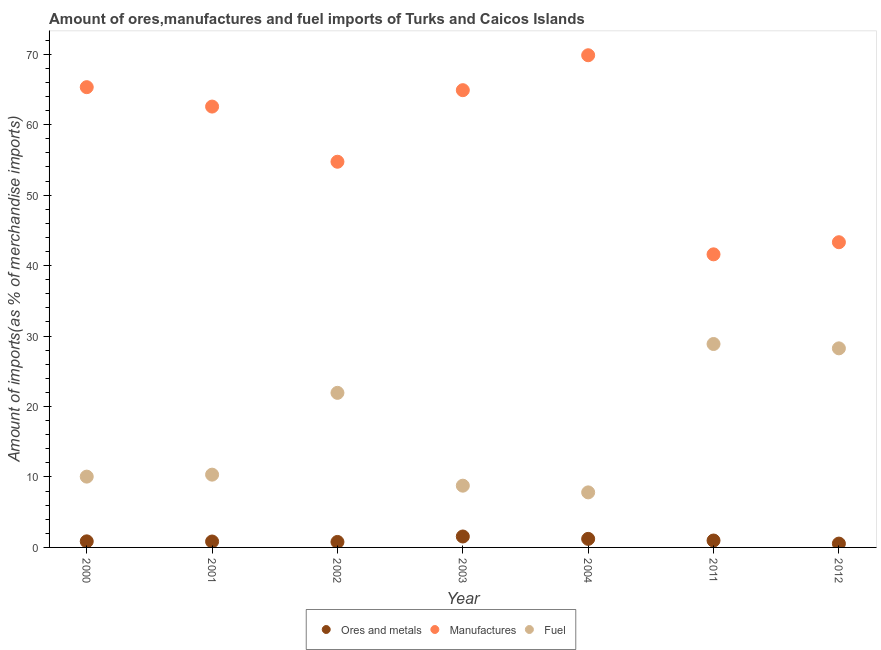What is the percentage of fuel imports in 2000?
Make the answer very short. 10.05. Across all years, what is the maximum percentage of ores and metals imports?
Your response must be concise. 1.55. Across all years, what is the minimum percentage of fuel imports?
Provide a short and direct response. 7.81. What is the total percentage of manufactures imports in the graph?
Offer a very short reply. 402.31. What is the difference between the percentage of ores and metals imports in 2000 and that in 2003?
Your answer should be very brief. -0.69. What is the difference between the percentage of fuel imports in 2012 and the percentage of ores and metals imports in 2004?
Ensure brevity in your answer.  27.04. What is the average percentage of manufactures imports per year?
Make the answer very short. 57.47. In the year 2001, what is the difference between the percentage of manufactures imports and percentage of fuel imports?
Your response must be concise. 52.24. In how many years, is the percentage of fuel imports greater than 14 %?
Provide a succinct answer. 3. What is the ratio of the percentage of manufactures imports in 2000 to that in 2012?
Your answer should be compact. 1.51. Is the percentage of ores and metals imports in 2000 less than that in 2002?
Offer a very short reply. No. What is the difference between the highest and the second highest percentage of ores and metals imports?
Your response must be concise. 0.34. What is the difference between the highest and the lowest percentage of ores and metals imports?
Your response must be concise. 1.01. Is the sum of the percentage of ores and metals imports in 2003 and 2012 greater than the maximum percentage of manufactures imports across all years?
Provide a succinct answer. No. How many dotlines are there?
Make the answer very short. 3. Are the values on the major ticks of Y-axis written in scientific E-notation?
Provide a succinct answer. No. Does the graph contain any zero values?
Offer a very short reply. No. How are the legend labels stacked?
Make the answer very short. Horizontal. What is the title of the graph?
Keep it short and to the point. Amount of ores,manufactures and fuel imports of Turks and Caicos Islands. Does "Agricultural Nitrous Oxide" appear as one of the legend labels in the graph?
Offer a terse response. No. What is the label or title of the X-axis?
Your response must be concise. Year. What is the label or title of the Y-axis?
Give a very brief answer. Amount of imports(as % of merchandise imports). What is the Amount of imports(as % of merchandise imports) of Ores and metals in 2000?
Make the answer very short. 0.86. What is the Amount of imports(as % of merchandise imports) of Manufactures in 2000?
Your answer should be compact. 65.32. What is the Amount of imports(as % of merchandise imports) in Fuel in 2000?
Ensure brevity in your answer.  10.05. What is the Amount of imports(as % of merchandise imports) in Ores and metals in 2001?
Offer a very short reply. 0.84. What is the Amount of imports(as % of merchandise imports) in Manufactures in 2001?
Offer a very short reply. 62.57. What is the Amount of imports(as % of merchandise imports) of Fuel in 2001?
Provide a succinct answer. 10.33. What is the Amount of imports(as % of merchandise imports) in Ores and metals in 2002?
Provide a short and direct response. 0.78. What is the Amount of imports(as % of merchandise imports) in Manufactures in 2002?
Make the answer very short. 54.74. What is the Amount of imports(as % of merchandise imports) in Fuel in 2002?
Your answer should be very brief. 21.94. What is the Amount of imports(as % of merchandise imports) in Ores and metals in 2003?
Your response must be concise. 1.55. What is the Amount of imports(as % of merchandise imports) in Manufactures in 2003?
Your answer should be very brief. 64.9. What is the Amount of imports(as % of merchandise imports) of Fuel in 2003?
Your response must be concise. 8.76. What is the Amount of imports(as % of merchandise imports) in Ores and metals in 2004?
Your answer should be compact. 1.21. What is the Amount of imports(as % of merchandise imports) in Manufactures in 2004?
Your answer should be very brief. 69.86. What is the Amount of imports(as % of merchandise imports) in Fuel in 2004?
Offer a terse response. 7.81. What is the Amount of imports(as % of merchandise imports) of Ores and metals in 2011?
Provide a succinct answer. 0.98. What is the Amount of imports(as % of merchandise imports) of Manufactures in 2011?
Provide a short and direct response. 41.6. What is the Amount of imports(as % of merchandise imports) of Fuel in 2011?
Give a very brief answer. 28.87. What is the Amount of imports(as % of merchandise imports) in Ores and metals in 2012?
Offer a terse response. 0.54. What is the Amount of imports(as % of merchandise imports) of Manufactures in 2012?
Your response must be concise. 43.32. What is the Amount of imports(as % of merchandise imports) in Fuel in 2012?
Offer a very short reply. 28.25. Across all years, what is the maximum Amount of imports(as % of merchandise imports) of Ores and metals?
Provide a short and direct response. 1.55. Across all years, what is the maximum Amount of imports(as % of merchandise imports) in Manufactures?
Give a very brief answer. 69.86. Across all years, what is the maximum Amount of imports(as % of merchandise imports) of Fuel?
Provide a short and direct response. 28.87. Across all years, what is the minimum Amount of imports(as % of merchandise imports) in Ores and metals?
Your answer should be very brief. 0.54. Across all years, what is the minimum Amount of imports(as % of merchandise imports) in Manufactures?
Your answer should be very brief. 41.6. Across all years, what is the minimum Amount of imports(as % of merchandise imports) of Fuel?
Your answer should be compact. 7.81. What is the total Amount of imports(as % of merchandise imports) of Ores and metals in the graph?
Your response must be concise. 6.77. What is the total Amount of imports(as % of merchandise imports) in Manufactures in the graph?
Your response must be concise. 402.31. What is the total Amount of imports(as % of merchandise imports) in Fuel in the graph?
Offer a very short reply. 116.02. What is the difference between the Amount of imports(as % of merchandise imports) of Ores and metals in 2000 and that in 2001?
Give a very brief answer. 0.02. What is the difference between the Amount of imports(as % of merchandise imports) of Manufactures in 2000 and that in 2001?
Your response must be concise. 2.75. What is the difference between the Amount of imports(as % of merchandise imports) of Fuel in 2000 and that in 2001?
Your answer should be very brief. -0.28. What is the difference between the Amount of imports(as % of merchandise imports) of Ores and metals in 2000 and that in 2002?
Provide a succinct answer. 0.08. What is the difference between the Amount of imports(as % of merchandise imports) in Manufactures in 2000 and that in 2002?
Your answer should be very brief. 10.58. What is the difference between the Amount of imports(as % of merchandise imports) in Fuel in 2000 and that in 2002?
Give a very brief answer. -11.89. What is the difference between the Amount of imports(as % of merchandise imports) of Ores and metals in 2000 and that in 2003?
Give a very brief answer. -0.69. What is the difference between the Amount of imports(as % of merchandise imports) in Manufactures in 2000 and that in 2003?
Offer a very short reply. 0.43. What is the difference between the Amount of imports(as % of merchandise imports) of Fuel in 2000 and that in 2003?
Ensure brevity in your answer.  1.29. What is the difference between the Amount of imports(as % of merchandise imports) of Ores and metals in 2000 and that in 2004?
Offer a terse response. -0.35. What is the difference between the Amount of imports(as % of merchandise imports) of Manufactures in 2000 and that in 2004?
Give a very brief answer. -4.53. What is the difference between the Amount of imports(as % of merchandise imports) of Fuel in 2000 and that in 2004?
Make the answer very short. 2.24. What is the difference between the Amount of imports(as % of merchandise imports) in Ores and metals in 2000 and that in 2011?
Make the answer very short. -0.12. What is the difference between the Amount of imports(as % of merchandise imports) in Manufactures in 2000 and that in 2011?
Keep it short and to the point. 23.73. What is the difference between the Amount of imports(as % of merchandise imports) of Fuel in 2000 and that in 2011?
Ensure brevity in your answer.  -18.82. What is the difference between the Amount of imports(as % of merchandise imports) of Ores and metals in 2000 and that in 2012?
Offer a very short reply. 0.32. What is the difference between the Amount of imports(as % of merchandise imports) in Manufactures in 2000 and that in 2012?
Your response must be concise. 22.01. What is the difference between the Amount of imports(as % of merchandise imports) of Fuel in 2000 and that in 2012?
Offer a terse response. -18.21. What is the difference between the Amount of imports(as % of merchandise imports) in Ores and metals in 2001 and that in 2002?
Offer a very short reply. 0.06. What is the difference between the Amount of imports(as % of merchandise imports) of Manufactures in 2001 and that in 2002?
Give a very brief answer. 7.83. What is the difference between the Amount of imports(as % of merchandise imports) of Fuel in 2001 and that in 2002?
Your response must be concise. -11.61. What is the difference between the Amount of imports(as % of merchandise imports) of Ores and metals in 2001 and that in 2003?
Keep it short and to the point. -0.71. What is the difference between the Amount of imports(as % of merchandise imports) in Manufactures in 2001 and that in 2003?
Offer a very short reply. -2.33. What is the difference between the Amount of imports(as % of merchandise imports) in Fuel in 2001 and that in 2003?
Ensure brevity in your answer.  1.57. What is the difference between the Amount of imports(as % of merchandise imports) in Ores and metals in 2001 and that in 2004?
Give a very brief answer. -0.37. What is the difference between the Amount of imports(as % of merchandise imports) of Manufactures in 2001 and that in 2004?
Offer a terse response. -7.29. What is the difference between the Amount of imports(as % of merchandise imports) of Fuel in 2001 and that in 2004?
Your response must be concise. 2.52. What is the difference between the Amount of imports(as % of merchandise imports) in Ores and metals in 2001 and that in 2011?
Provide a short and direct response. -0.14. What is the difference between the Amount of imports(as % of merchandise imports) of Manufactures in 2001 and that in 2011?
Provide a short and direct response. 20.97. What is the difference between the Amount of imports(as % of merchandise imports) of Fuel in 2001 and that in 2011?
Offer a very short reply. -18.54. What is the difference between the Amount of imports(as % of merchandise imports) of Ores and metals in 2001 and that in 2012?
Provide a succinct answer. 0.3. What is the difference between the Amount of imports(as % of merchandise imports) in Manufactures in 2001 and that in 2012?
Your answer should be compact. 19.25. What is the difference between the Amount of imports(as % of merchandise imports) of Fuel in 2001 and that in 2012?
Offer a very short reply. -17.93. What is the difference between the Amount of imports(as % of merchandise imports) of Ores and metals in 2002 and that in 2003?
Give a very brief answer. -0.77. What is the difference between the Amount of imports(as % of merchandise imports) of Manufactures in 2002 and that in 2003?
Your answer should be compact. -10.16. What is the difference between the Amount of imports(as % of merchandise imports) of Fuel in 2002 and that in 2003?
Offer a very short reply. 13.18. What is the difference between the Amount of imports(as % of merchandise imports) in Ores and metals in 2002 and that in 2004?
Your answer should be very brief. -0.44. What is the difference between the Amount of imports(as % of merchandise imports) in Manufactures in 2002 and that in 2004?
Provide a short and direct response. -15.12. What is the difference between the Amount of imports(as % of merchandise imports) of Fuel in 2002 and that in 2004?
Offer a terse response. 14.13. What is the difference between the Amount of imports(as % of merchandise imports) of Ores and metals in 2002 and that in 2011?
Ensure brevity in your answer.  -0.2. What is the difference between the Amount of imports(as % of merchandise imports) of Manufactures in 2002 and that in 2011?
Ensure brevity in your answer.  13.14. What is the difference between the Amount of imports(as % of merchandise imports) of Fuel in 2002 and that in 2011?
Provide a succinct answer. -6.93. What is the difference between the Amount of imports(as % of merchandise imports) in Ores and metals in 2002 and that in 2012?
Offer a terse response. 0.23. What is the difference between the Amount of imports(as % of merchandise imports) of Manufactures in 2002 and that in 2012?
Offer a terse response. 11.42. What is the difference between the Amount of imports(as % of merchandise imports) in Fuel in 2002 and that in 2012?
Your answer should be very brief. -6.32. What is the difference between the Amount of imports(as % of merchandise imports) in Ores and metals in 2003 and that in 2004?
Your response must be concise. 0.34. What is the difference between the Amount of imports(as % of merchandise imports) of Manufactures in 2003 and that in 2004?
Your response must be concise. -4.96. What is the difference between the Amount of imports(as % of merchandise imports) of Fuel in 2003 and that in 2004?
Provide a succinct answer. 0.95. What is the difference between the Amount of imports(as % of merchandise imports) in Ores and metals in 2003 and that in 2011?
Make the answer very short. 0.57. What is the difference between the Amount of imports(as % of merchandise imports) in Manufactures in 2003 and that in 2011?
Make the answer very short. 23.3. What is the difference between the Amount of imports(as % of merchandise imports) in Fuel in 2003 and that in 2011?
Ensure brevity in your answer.  -20.11. What is the difference between the Amount of imports(as % of merchandise imports) in Ores and metals in 2003 and that in 2012?
Ensure brevity in your answer.  1.01. What is the difference between the Amount of imports(as % of merchandise imports) of Manufactures in 2003 and that in 2012?
Your answer should be compact. 21.58. What is the difference between the Amount of imports(as % of merchandise imports) of Fuel in 2003 and that in 2012?
Ensure brevity in your answer.  -19.49. What is the difference between the Amount of imports(as % of merchandise imports) of Ores and metals in 2004 and that in 2011?
Offer a very short reply. 0.23. What is the difference between the Amount of imports(as % of merchandise imports) of Manufactures in 2004 and that in 2011?
Your response must be concise. 28.26. What is the difference between the Amount of imports(as % of merchandise imports) of Fuel in 2004 and that in 2011?
Your response must be concise. -21.06. What is the difference between the Amount of imports(as % of merchandise imports) in Ores and metals in 2004 and that in 2012?
Provide a succinct answer. 0.67. What is the difference between the Amount of imports(as % of merchandise imports) of Manufactures in 2004 and that in 2012?
Make the answer very short. 26.54. What is the difference between the Amount of imports(as % of merchandise imports) of Fuel in 2004 and that in 2012?
Keep it short and to the point. -20.44. What is the difference between the Amount of imports(as % of merchandise imports) of Ores and metals in 2011 and that in 2012?
Your response must be concise. 0.44. What is the difference between the Amount of imports(as % of merchandise imports) of Manufactures in 2011 and that in 2012?
Provide a short and direct response. -1.72. What is the difference between the Amount of imports(as % of merchandise imports) of Fuel in 2011 and that in 2012?
Offer a terse response. 0.62. What is the difference between the Amount of imports(as % of merchandise imports) of Ores and metals in 2000 and the Amount of imports(as % of merchandise imports) of Manufactures in 2001?
Your answer should be compact. -61.71. What is the difference between the Amount of imports(as % of merchandise imports) of Ores and metals in 2000 and the Amount of imports(as % of merchandise imports) of Fuel in 2001?
Keep it short and to the point. -9.47. What is the difference between the Amount of imports(as % of merchandise imports) of Manufactures in 2000 and the Amount of imports(as % of merchandise imports) of Fuel in 2001?
Give a very brief answer. 55. What is the difference between the Amount of imports(as % of merchandise imports) of Ores and metals in 2000 and the Amount of imports(as % of merchandise imports) of Manufactures in 2002?
Your answer should be compact. -53.88. What is the difference between the Amount of imports(as % of merchandise imports) in Ores and metals in 2000 and the Amount of imports(as % of merchandise imports) in Fuel in 2002?
Your response must be concise. -21.08. What is the difference between the Amount of imports(as % of merchandise imports) of Manufactures in 2000 and the Amount of imports(as % of merchandise imports) of Fuel in 2002?
Provide a short and direct response. 43.39. What is the difference between the Amount of imports(as % of merchandise imports) of Ores and metals in 2000 and the Amount of imports(as % of merchandise imports) of Manufactures in 2003?
Keep it short and to the point. -64.04. What is the difference between the Amount of imports(as % of merchandise imports) of Ores and metals in 2000 and the Amount of imports(as % of merchandise imports) of Fuel in 2003?
Ensure brevity in your answer.  -7.9. What is the difference between the Amount of imports(as % of merchandise imports) of Manufactures in 2000 and the Amount of imports(as % of merchandise imports) of Fuel in 2003?
Make the answer very short. 56.56. What is the difference between the Amount of imports(as % of merchandise imports) in Ores and metals in 2000 and the Amount of imports(as % of merchandise imports) in Manufactures in 2004?
Offer a terse response. -68.99. What is the difference between the Amount of imports(as % of merchandise imports) of Ores and metals in 2000 and the Amount of imports(as % of merchandise imports) of Fuel in 2004?
Ensure brevity in your answer.  -6.95. What is the difference between the Amount of imports(as % of merchandise imports) of Manufactures in 2000 and the Amount of imports(as % of merchandise imports) of Fuel in 2004?
Give a very brief answer. 57.51. What is the difference between the Amount of imports(as % of merchandise imports) of Ores and metals in 2000 and the Amount of imports(as % of merchandise imports) of Manufactures in 2011?
Keep it short and to the point. -40.74. What is the difference between the Amount of imports(as % of merchandise imports) in Ores and metals in 2000 and the Amount of imports(as % of merchandise imports) in Fuel in 2011?
Your response must be concise. -28.01. What is the difference between the Amount of imports(as % of merchandise imports) of Manufactures in 2000 and the Amount of imports(as % of merchandise imports) of Fuel in 2011?
Offer a very short reply. 36.45. What is the difference between the Amount of imports(as % of merchandise imports) in Ores and metals in 2000 and the Amount of imports(as % of merchandise imports) in Manufactures in 2012?
Give a very brief answer. -42.46. What is the difference between the Amount of imports(as % of merchandise imports) of Ores and metals in 2000 and the Amount of imports(as % of merchandise imports) of Fuel in 2012?
Make the answer very short. -27.39. What is the difference between the Amount of imports(as % of merchandise imports) of Manufactures in 2000 and the Amount of imports(as % of merchandise imports) of Fuel in 2012?
Give a very brief answer. 37.07. What is the difference between the Amount of imports(as % of merchandise imports) in Ores and metals in 2001 and the Amount of imports(as % of merchandise imports) in Manufactures in 2002?
Ensure brevity in your answer.  -53.9. What is the difference between the Amount of imports(as % of merchandise imports) of Ores and metals in 2001 and the Amount of imports(as % of merchandise imports) of Fuel in 2002?
Your answer should be compact. -21.1. What is the difference between the Amount of imports(as % of merchandise imports) of Manufactures in 2001 and the Amount of imports(as % of merchandise imports) of Fuel in 2002?
Offer a very short reply. 40.63. What is the difference between the Amount of imports(as % of merchandise imports) of Ores and metals in 2001 and the Amount of imports(as % of merchandise imports) of Manufactures in 2003?
Your response must be concise. -64.06. What is the difference between the Amount of imports(as % of merchandise imports) in Ores and metals in 2001 and the Amount of imports(as % of merchandise imports) in Fuel in 2003?
Your answer should be very brief. -7.92. What is the difference between the Amount of imports(as % of merchandise imports) of Manufactures in 2001 and the Amount of imports(as % of merchandise imports) of Fuel in 2003?
Give a very brief answer. 53.81. What is the difference between the Amount of imports(as % of merchandise imports) of Ores and metals in 2001 and the Amount of imports(as % of merchandise imports) of Manufactures in 2004?
Give a very brief answer. -69.02. What is the difference between the Amount of imports(as % of merchandise imports) in Ores and metals in 2001 and the Amount of imports(as % of merchandise imports) in Fuel in 2004?
Your answer should be very brief. -6.97. What is the difference between the Amount of imports(as % of merchandise imports) of Manufactures in 2001 and the Amount of imports(as % of merchandise imports) of Fuel in 2004?
Offer a terse response. 54.76. What is the difference between the Amount of imports(as % of merchandise imports) of Ores and metals in 2001 and the Amount of imports(as % of merchandise imports) of Manufactures in 2011?
Your answer should be compact. -40.76. What is the difference between the Amount of imports(as % of merchandise imports) in Ores and metals in 2001 and the Amount of imports(as % of merchandise imports) in Fuel in 2011?
Provide a succinct answer. -28.03. What is the difference between the Amount of imports(as % of merchandise imports) in Manufactures in 2001 and the Amount of imports(as % of merchandise imports) in Fuel in 2011?
Provide a succinct answer. 33.7. What is the difference between the Amount of imports(as % of merchandise imports) in Ores and metals in 2001 and the Amount of imports(as % of merchandise imports) in Manufactures in 2012?
Provide a succinct answer. -42.48. What is the difference between the Amount of imports(as % of merchandise imports) in Ores and metals in 2001 and the Amount of imports(as % of merchandise imports) in Fuel in 2012?
Your answer should be compact. -27.41. What is the difference between the Amount of imports(as % of merchandise imports) in Manufactures in 2001 and the Amount of imports(as % of merchandise imports) in Fuel in 2012?
Your answer should be compact. 34.32. What is the difference between the Amount of imports(as % of merchandise imports) in Ores and metals in 2002 and the Amount of imports(as % of merchandise imports) in Manufactures in 2003?
Your answer should be compact. -64.12. What is the difference between the Amount of imports(as % of merchandise imports) of Ores and metals in 2002 and the Amount of imports(as % of merchandise imports) of Fuel in 2003?
Give a very brief answer. -7.99. What is the difference between the Amount of imports(as % of merchandise imports) of Manufactures in 2002 and the Amount of imports(as % of merchandise imports) of Fuel in 2003?
Offer a terse response. 45.98. What is the difference between the Amount of imports(as % of merchandise imports) of Ores and metals in 2002 and the Amount of imports(as % of merchandise imports) of Manufactures in 2004?
Provide a succinct answer. -69.08. What is the difference between the Amount of imports(as % of merchandise imports) of Ores and metals in 2002 and the Amount of imports(as % of merchandise imports) of Fuel in 2004?
Give a very brief answer. -7.04. What is the difference between the Amount of imports(as % of merchandise imports) of Manufactures in 2002 and the Amount of imports(as % of merchandise imports) of Fuel in 2004?
Make the answer very short. 46.93. What is the difference between the Amount of imports(as % of merchandise imports) in Ores and metals in 2002 and the Amount of imports(as % of merchandise imports) in Manufactures in 2011?
Give a very brief answer. -40.82. What is the difference between the Amount of imports(as % of merchandise imports) of Ores and metals in 2002 and the Amount of imports(as % of merchandise imports) of Fuel in 2011?
Keep it short and to the point. -28.09. What is the difference between the Amount of imports(as % of merchandise imports) of Manufactures in 2002 and the Amount of imports(as % of merchandise imports) of Fuel in 2011?
Your answer should be very brief. 25.87. What is the difference between the Amount of imports(as % of merchandise imports) in Ores and metals in 2002 and the Amount of imports(as % of merchandise imports) in Manufactures in 2012?
Ensure brevity in your answer.  -42.54. What is the difference between the Amount of imports(as % of merchandise imports) of Ores and metals in 2002 and the Amount of imports(as % of merchandise imports) of Fuel in 2012?
Keep it short and to the point. -27.48. What is the difference between the Amount of imports(as % of merchandise imports) in Manufactures in 2002 and the Amount of imports(as % of merchandise imports) in Fuel in 2012?
Your answer should be very brief. 26.49. What is the difference between the Amount of imports(as % of merchandise imports) of Ores and metals in 2003 and the Amount of imports(as % of merchandise imports) of Manufactures in 2004?
Make the answer very short. -68.3. What is the difference between the Amount of imports(as % of merchandise imports) of Ores and metals in 2003 and the Amount of imports(as % of merchandise imports) of Fuel in 2004?
Your answer should be compact. -6.26. What is the difference between the Amount of imports(as % of merchandise imports) in Manufactures in 2003 and the Amount of imports(as % of merchandise imports) in Fuel in 2004?
Your answer should be very brief. 57.08. What is the difference between the Amount of imports(as % of merchandise imports) of Ores and metals in 2003 and the Amount of imports(as % of merchandise imports) of Manufactures in 2011?
Keep it short and to the point. -40.05. What is the difference between the Amount of imports(as % of merchandise imports) of Ores and metals in 2003 and the Amount of imports(as % of merchandise imports) of Fuel in 2011?
Your response must be concise. -27.32. What is the difference between the Amount of imports(as % of merchandise imports) in Manufactures in 2003 and the Amount of imports(as % of merchandise imports) in Fuel in 2011?
Keep it short and to the point. 36.03. What is the difference between the Amount of imports(as % of merchandise imports) of Ores and metals in 2003 and the Amount of imports(as % of merchandise imports) of Manufactures in 2012?
Offer a terse response. -41.77. What is the difference between the Amount of imports(as % of merchandise imports) in Ores and metals in 2003 and the Amount of imports(as % of merchandise imports) in Fuel in 2012?
Offer a terse response. -26.7. What is the difference between the Amount of imports(as % of merchandise imports) of Manufactures in 2003 and the Amount of imports(as % of merchandise imports) of Fuel in 2012?
Make the answer very short. 36.64. What is the difference between the Amount of imports(as % of merchandise imports) in Ores and metals in 2004 and the Amount of imports(as % of merchandise imports) in Manufactures in 2011?
Offer a terse response. -40.38. What is the difference between the Amount of imports(as % of merchandise imports) in Ores and metals in 2004 and the Amount of imports(as % of merchandise imports) in Fuel in 2011?
Provide a short and direct response. -27.66. What is the difference between the Amount of imports(as % of merchandise imports) of Manufactures in 2004 and the Amount of imports(as % of merchandise imports) of Fuel in 2011?
Ensure brevity in your answer.  40.98. What is the difference between the Amount of imports(as % of merchandise imports) of Ores and metals in 2004 and the Amount of imports(as % of merchandise imports) of Manufactures in 2012?
Your answer should be very brief. -42.1. What is the difference between the Amount of imports(as % of merchandise imports) of Ores and metals in 2004 and the Amount of imports(as % of merchandise imports) of Fuel in 2012?
Your answer should be compact. -27.04. What is the difference between the Amount of imports(as % of merchandise imports) of Manufactures in 2004 and the Amount of imports(as % of merchandise imports) of Fuel in 2012?
Your answer should be very brief. 41.6. What is the difference between the Amount of imports(as % of merchandise imports) of Ores and metals in 2011 and the Amount of imports(as % of merchandise imports) of Manufactures in 2012?
Provide a succinct answer. -42.34. What is the difference between the Amount of imports(as % of merchandise imports) of Ores and metals in 2011 and the Amount of imports(as % of merchandise imports) of Fuel in 2012?
Your answer should be compact. -27.27. What is the difference between the Amount of imports(as % of merchandise imports) in Manufactures in 2011 and the Amount of imports(as % of merchandise imports) in Fuel in 2012?
Your answer should be very brief. 13.34. What is the average Amount of imports(as % of merchandise imports) in Ores and metals per year?
Your answer should be very brief. 0.97. What is the average Amount of imports(as % of merchandise imports) of Manufactures per year?
Your response must be concise. 57.47. What is the average Amount of imports(as % of merchandise imports) in Fuel per year?
Offer a terse response. 16.57. In the year 2000, what is the difference between the Amount of imports(as % of merchandise imports) of Ores and metals and Amount of imports(as % of merchandise imports) of Manufactures?
Provide a short and direct response. -64.46. In the year 2000, what is the difference between the Amount of imports(as % of merchandise imports) in Ores and metals and Amount of imports(as % of merchandise imports) in Fuel?
Your response must be concise. -9.19. In the year 2000, what is the difference between the Amount of imports(as % of merchandise imports) in Manufactures and Amount of imports(as % of merchandise imports) in Fuel?
Give a very brief answer. 55.28. In the year 2001, what is the difference between the Amount of imports(as % of merchandise imports) in Ores and metals and Amount of imports(as % of merchandise imports) in Manufactures?
Keep it short and to the point. -61.73. In the year 2001, what is the difference between the Amount of imports(as % of merchandise imports) in Ores and metals and Amount of imports(as % of merchandise imports) in Fuel?
Give a very brief answer. -9.49. In the year 2001, what is the difference between the Amount of imports(as % of merchandise imports) in Manufactures and Amount of imports(as % of merchandise imports) in Fuel?
Ensure brevity in your answer.  52.24. In the year 2002, what is the difference between the Amount of imports(as % of merchandise imports) of Ores and metals and Amount of imports(as % of merchandise imports) of Manufactures?
Provide a succinct answer. -53.96. In the year 2002, what is the difference between the Amount of imports(as % of merchandise imports) in Ores and metals and Amount of imports(as % of merchandise imports) in Fuel?
Give a very brief answer. -21.16. In the year 2002, what is the difference between the Amount of imports(as % of merchandise imports) of Manufactures and Amount of imports(as % of merchandise imports) of Fuel?
Make the answer very short. 32.8. In the year 2003, what is the difference between the Amount of imports(as % of merchandise imports) in Ores and metals and Amount of imports(as % of merchandise imports) in Manufactures?
Ensure brevity in your answer.  -63.35. In the year 2003, what is the difference between the Amount of imports(as % of merchandise imports) of Ores and metals and Amount of imports(as % of merchandise imports) of Fuel?
Your response must be concise. -7.21. In the year 2003, what is the difference between the Amount of imports(as % of merchandise imports) of Manufactures and Amount of imports(as % of merchandise imports) of Fuel?
Provide a short and direct response. 56.13. In the year 2004, what is the difference between the Amount of imports(as % of merchandise imports) in Ores and metals and Amount of imports(as % of merchandise imports) in Manufactures?
Your answer should be very brief. -68.64. In the year 2004, what is the difference between the Amount of imports(as % of merchandise imports) in Ores and metals and Amount of imports(as % of merchandise imports) in Fuel?
Your answer should be compact. -6.6. In the year 2004, what is the difference between the Amount of imports(as % of merchandise imports) of Manufactures and Amount of imports(as % of merchandise imports) of Fuel?
Ensure brevity in your answer.  62.04. In the year 2011, what is the difference between the Amount of imports(as % of merchandise imports) of Ores and metals and Amount of imports(as % of merchandise imports) of Manufactures?
Provide a short and direct response. -40.62. In the year 2011, what is the difference between the Amount of imports(as % of merchandise imports) in Ores and metals and Amount of imports(as % of merchandise imports) in Fuel?
Your answer should be compact. -27.89. In the year 2011, what is the difference between the Amount of imports(as % of merchandise imports) in Manufactures and Amount of imports(as % of merchandise imports) in Fuel?
Give a very brief answer. 12.73. In the year 2012, what is the difference between the Amount of imports(as % of merchandise imports) in Ores and metals and Amount of imports(as % of merchandise imports) in Manufactures?
Offer a very short reply. -42.77. In the year 2012, what is the difference between the Amount of imports(as % of merchandise imports) in Ores and metals and Amount of imports(as % of merchandise imports) in Fuel?
Give a very brief answer. -27.71. In the year 2012, what is the difference between the Amount of imports(as % of merchandise imports) of Manufactures and Amount of imports(as % of merchandise imports) of Fuel?
Give a very brief answer. 15.06. What is the ratio of the Amount of imports(as % of merchandise imports) in Ores and metals in 2000 to that in 2001?
Your answer should be compact. 1.03. What is the ratio of the Amount of imports(as % of merchandise imports) in Manufactures in 2000 to that in 2001?
Your answer should be very brief. 1.04. What is the ratio of the Amount of imports(as % of merchandise imports) of Fuel in 2000 to that in 2001?
Make the answer very short. 0.97. What is the ratio of the Amount of imports(as % of merchandise imports) of Ores and metals in 2000 to that in 2002?
Offer a terse response. 1.11. What is the ratio of the Amount of imports(as % of merchandise imports) of Manufactures in 2000 to that in 2002?
Provide a short and direct response. 1.19. What is the ratio of the Amount of imports(as % of merchandise imports) of Fuel in 2000 to that in 2002?
Offer a very short reply. 0.46. What is the ratio of the Amount of imports(as % of merchandise imports) in Ores and metals in 2000 to that in 2003?
Offer a very short reply. 0.56. What is the ratio of the Amount of imports(as % of merchandise imports) in Manufactures in 2000 to that in 2003?
Offer a terse response. 1.01. What is the ratio of the Amount of imports(as % of merchandise imports) in Fuel in 2000 to that in 2003?
Offer a terse response. 1.15. What is the ratio of the Amount of imports(as % of merchandise imports) of Ores and metals in 2000 to that in 2004?
Your answer should be compact. 0.71. What is the ratio of the Amount of imports(as % of merchandise imports) in Manufactures in 2000 to that in 2004?
Provide a short and direct response. 0.94. What is the ratio of the Amount of imports(as % of merchandise imports) in Fuel in 2000 to that in 2004?
Make the answer very short. 1.29. What is the ratio of the Amount of imports(as % of merchandise imports) in Ores and metals in 2000 to that in 2011?
Offer a very short reply. 0.88. What is the ratio of the Amount of imports(as % of merchandise imports) of Manufactures in 2000 to that in 2011?
Provide a succinct answer. 1.57. What is the ratio of the Amount of imports(as % of merchandise imports) in Fuel in 2000 to that in 2011?
Ensure brevity in your answer.  0.35. What is the ratio of the Amount of imports(as % of merchandise imports) of Ores and metals in 2000 to that in 2012?
Offer a terse response. 1.59. What is the ratio of the Amount of imports(as % of merchandise imports) of Manufactures in 2000 to that in 2012?
Your response must be concise. 1.51. What is the ratio of the Amount of imports(as % of merchandise imports) of Fuel in 2000 to that in 2012?
Your answer should be compact. 0.36. What is the ratio of the Amount of imports(as % of merchandise imports) in Ores and metals in 2001 to that in 2002?
Keep it short and to the point. 1.08. What is the ratio of the Amount of imports(as % of merchandise imports) in Manufactures in 2001 to that in 2002?
Your answer should be very brief. 1.14. What is the ratio of the Amount of imports(as % of merchandise imports) in Fuel in 2001 to that in 2002?
Provide a short and direct response. 0.47. What is the ratio of the Amount of imports(as % of merchandise imports) in Ores and metals in 2001 to that in 2003?
Make the answer very short. 0.54. What is the ratio of the Amount of imports(as % of merchandise imports) in Manufactures in 2001 to that in 2003?
Ensure brevity in your answer.  0.96. What is the ratio of the Amount of imports(as % of merchandise imports) of Fuel in 2001 to that in 2003?
Offer a very short reply. 1.18. What is the ratio of the Amount of imports(as % of merchandise imports) of Ores and metals in 2001 to that in 2004?
Offer a very short reply. 0.69. What is the ratio of the Amount of imports(as % of merchandise imports) of Manufactures in 2001 to that in 2004?
Keep it short and to the point. 0.9. What is the ratio of the Amount of imports(as % of merchandise imports) of Fuel in 2001 to that in 2004?
Your response must be concise. 1.32. What is the ratio of the Amount of imports(as % of merchandise imports) of Ores and metals in 2001 to that in 2011?
Keep it short and to the point. 0.86. What is the ratio of the Amount of imports(as % of merchandise imports) of Manufactures in 2001 to that in 2011?
Offer a very short reply. 1.5. What is the ratio of the Amount of imports(as % of merchandise imports) of Fuel in 2001 to that in 2011?
Ensure brevity in your answer.  0.36. What is the ratio of the Amount of imports(as % of merchandise imports) in Ores and metals in 2001 to that in 2012?
Keep it short and to the point. 1.54. What is the ratio of the Amount of imports(as % of merchandise imports) of Manufactures in 2001 to that in 2012?
Keep it short and to the point. 1.44. What is the ratio of the Amount of imports(as % of merchandise imports) of Fuel in 2001 to that in 2012?
Ensure brevity in your answer.  0.37. What is the ratio of the Amount of imports(as % of merchandise imports) of Ores and metals in 2002 to that in 2003?
Provide a succinct answer. 0.5. What is the ratio of the Amount of imports(as % of merchandise imports) in Manufactures in 2002 to that in 2003?
Keep it short and to the point. 0.84. What is the ratio of the Amount of imports(as % of merchandise imports) in Fuel in 2002 to that in 2003?
Your answer should be very brief. 2.5. What is the ratio of the Amount of imports(as % of merchandise imports) in Ores and metals in 2002 to that in 2004?
Provide a short and direct response. 0.64. What is the ratio of the Amount of imports(as % of merchandise imports) in Manufactures in 2002 to that in 2004?
Your response must be concise. 0.78. What is the ratio of the Amount of imports(as % of merchandise imports) of Fuel in 2002 to that in 2004?
Your answer should be very brief. 2.81. What is the ratio of the Amount of imports(as % of merchandise imports) in Ores and metals in 2002 to that in 2011?
Offer a very short reply. 0.79. What is the ratio of the Amount of imports(as % of merchandise imports) in Manufactures in 2002 to that in 2011?
Make the answer very short. 1.32. What is the ratio of the Amount of imports(as % of merchandise imports) of Fuel in 2002 to that in 2011?
Provide a short and direct response. 0.76. What is the ratio of the Amount of imports(as % of merchandise imports) of Ores and metals in 2002 to that in 2012?
Your answer should be compact. 1.43. What is the ratio of the Amount of imports(as % of merchandise imports) of Manufactures in 2002 to that in 2012?
Keep it short and to the point. 1.26. What is the ratio of the Amount of imports(as % of merchandise imports) in Fuel in 2002 to that in 2012?
Offer a very short reply. 0.78. What is the ratio of the Amount of imports(as % of merchandise imports) of Ores and metals in 2003 to that in 2004?
Make the answer very short. 1.28. What is the ratio of the Amount of imports(as % of merchandise imports) in Manufactures in 2003 to that in 2004?
Offer a very short reply. 0.93. What is the ratio of the Amount of imports(as % of merchandise imports) in Fuel in 2003 to that in 2004?
Your answer should be very brief. 1.12. What is the ratio of the Amount of imports(as % of merchandise imports) of Ores and metals in 2003 to that in 2011?
Offer a very short reply. 1.58. What is the ratio of the Amount of imports(as % of merchandise imports) in Manufactures in 2003 to that in 2011?
Make the answer very short. 1.56. What is the ratio of the Amount of imports(as % of merchandise imports) of Fuel in 2003 to that in 2011?
Offer a terse response. 0.3. What is the ratio of the Amount of imports(as % of merchandise imports) in Ores and metals in 2003 to that in 2012?
Ensure brevity in your answer.  2.85. What is the ratio of the Amount of imports(as % of merchandise imports) of Manufactures in 2003 to that in 2012?
Offer a very short reply. 1.5. What is the ratio of the Amount of imports(as % of merchandise imports) of Fuel in 2003 to that in 2012?
Ensure brevity in your answer.  0.31. What is the ratio of the Amount of imports(as % of merchandise imports) in Ores and metals in 2004 to that in 2011?
Make the answer very short. 1.24. What is the ratio of the Amount of imports(as % of merchandise imports) of Manufactures in 2004 to that in 2011?
Give a very brief answer. 1.68. What is the ratio of the Amount of imports(as % of merchandise imports) in Fuel in 2004 to that in 2011?
Provide a succinct answer. 0.27. What is the ratio of the Amount of imports(as % of merchandise imports) of Ores and metals in 2004 to that in 2012?
Give a very brief answer. 2.23. What is the ratio of the Amount of imports(as % of merchandise imports) of Manufactures in 2004 to that in 2012?
Make the answer very short. 1.61. What is the ratio of the Amount of imports(as % of merchandise imports) in Fuel in 2004 to that in 2012?
Provide a succinct answer. 0.28. What is the ratio of the Amount of imports(as % of merchandise imports) in Ores and metals in 2011 to that in 2012?
Keep it short and to the point. 1.8. What is the ratio of the Amount of imports(as % of merchandise imports) of Manufactures in 2011 to that in 2012?
Ensure brevity in your answer.  0.96. What is the ratio of the Amount of imports(as % of merchandise imports) of Fuel in 2011 to that in 2012?
Provide a succinct answer. 1.02. What is the difference between the highest and the second highest Amount of imports(as % of merchandise imports) in Ores and metals?
Provide a short and direct response. 0.34. What is the difference between the highest and the second highest Amount of imports(as % of merchandise imports) of Manufactures?
Give a very brief answer. 4.53. What is the difference between the highest and the second highest Amount of imports(as % of merchandise imports) of Fuel?
Offer a very short reply. 0.62. What is the difference between the highest and the lowest Amount of imports(as % of merchandise imports) of Ores and metals?
Ensure brevity in your answer.  1.01. What is the difference between the highest and the lowest Amount of imports(as % of merchandise imports) of Manufactures?
Ensure brevity in your answer.  28.26. What is the difference between the highest and the lowest Amount of imports(as % of merchandise imports) of Fuel?
Make the answer very short. 21.06. 